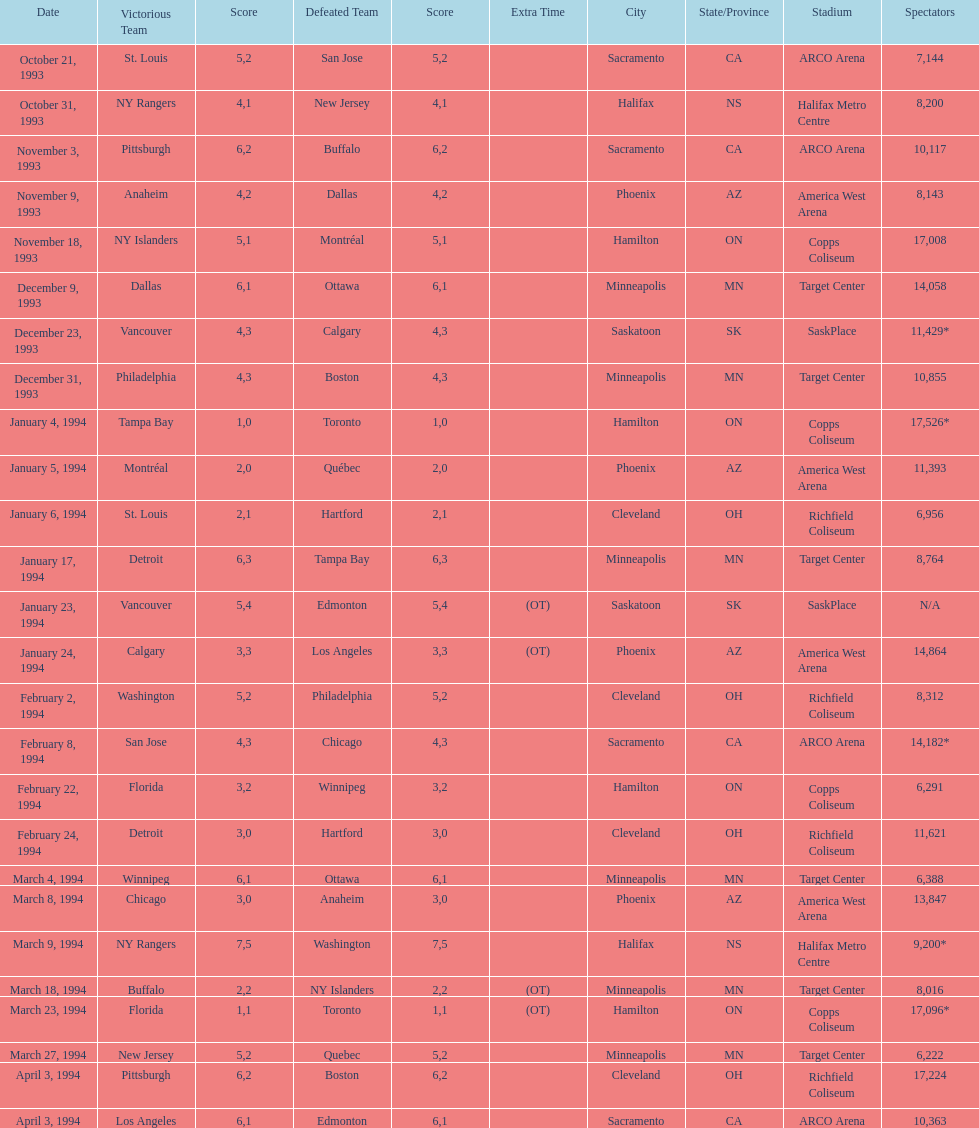When was the first neutral site game to be won by tampa bay? January 4, 1994. 